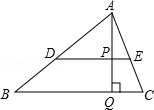Explore the implications of line DE being parallel to line BC in terms of the triangle's geometry. Lines DE and BC being parallel implies several geometric implications, such as the formation of corresponding angles and the potential similarity between certain triangles in the diagram. For instance, triangles APD and APB may be similar due to angle-angle similarity, which arises because of the parallel lines and the transversal lines intersecting them. 